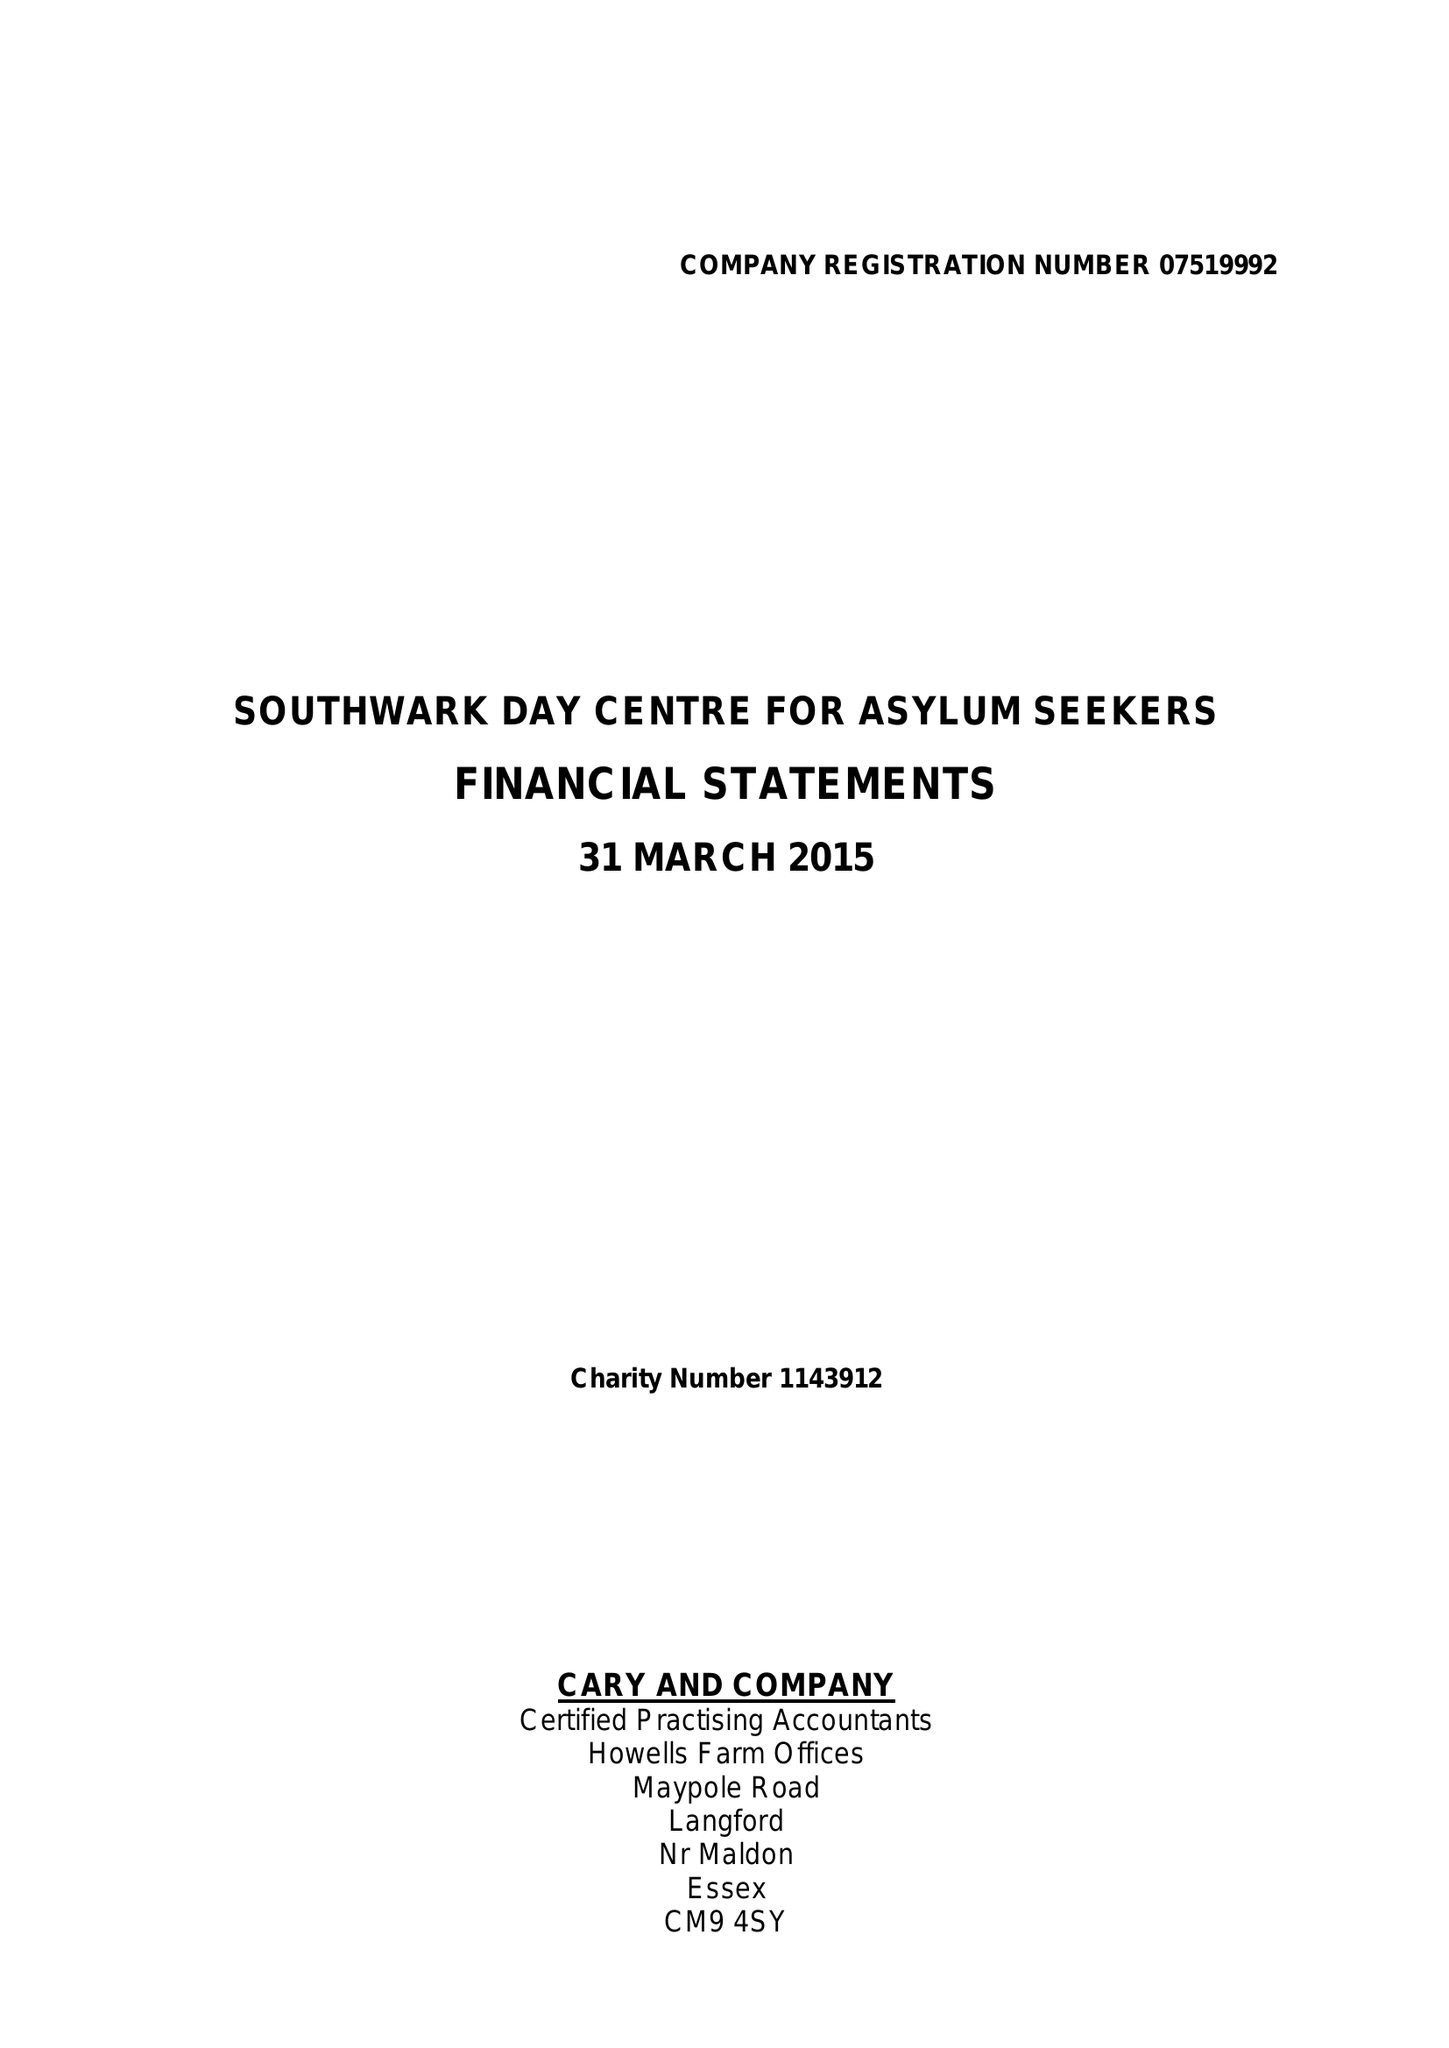What is the value for the address__postcode?
Answer the question using a single word or phrase. None 